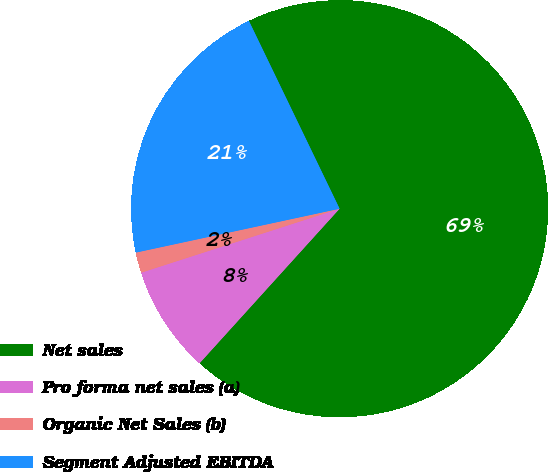<chart> <loc_0><loc_0><loc_500><loc_500><pie_chart><fcel>Net sales<fcel>Pro forma net sales (a)<fcel>Organic Net Sales (b)<fcel>Segment Adjusted EBITDA<nl><fcel>68.88%<fcel>8.32%<fcel>1.59%<fcel>21.22%<nl></chart> 